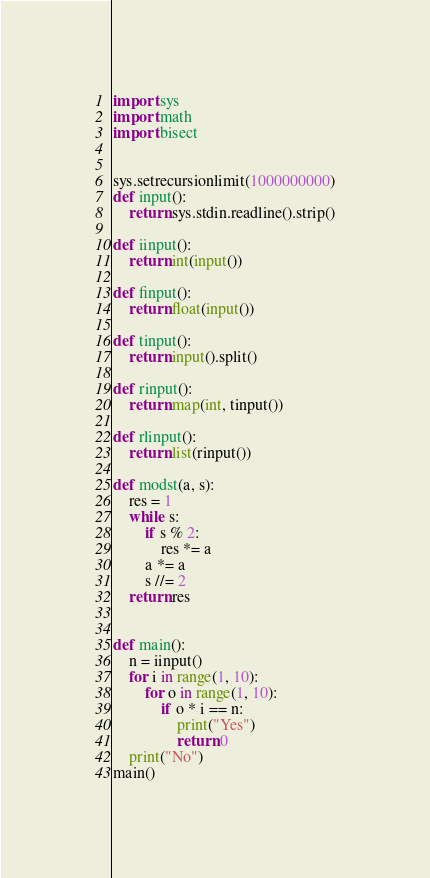Convert code to text. <code><loc_0><loc_0><loc_500><loc_500><_Python_>import sys
import math
import bisect
 
 
sys.setrecursionlimit(1000000000)
def input():
    return sys.stdin.readline().strip()
 
def iinput():
    return int(input())
 
def finput():
    return float(input())
 
def tinput():
    return input().split()
 
def rinput():
    return map(int, tinput())
 
def rlinput():
    return list(rinput())
 
def modst(a, s):
    res = 1
    while s:
        if s % 2:
            res *= a
        a *= a
        s //= 2
    return res

 
def main():
    n = iinput()
    for i in range(1, 10):
        for o in range(1, 10):
            if o * i == n:
                print("Yes")
                return 0
    print("No")
main()</code> 